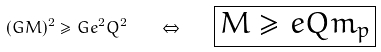<formula> <loc_0><loc_0><loc_500><loc_500>( G M ) ^ { 2 } \geq G e ^ { 2 } Q ^ { 2 } \quad \Leftrightarrow \quad \boxed { M \geq e Q m _ { p } }</formula> 